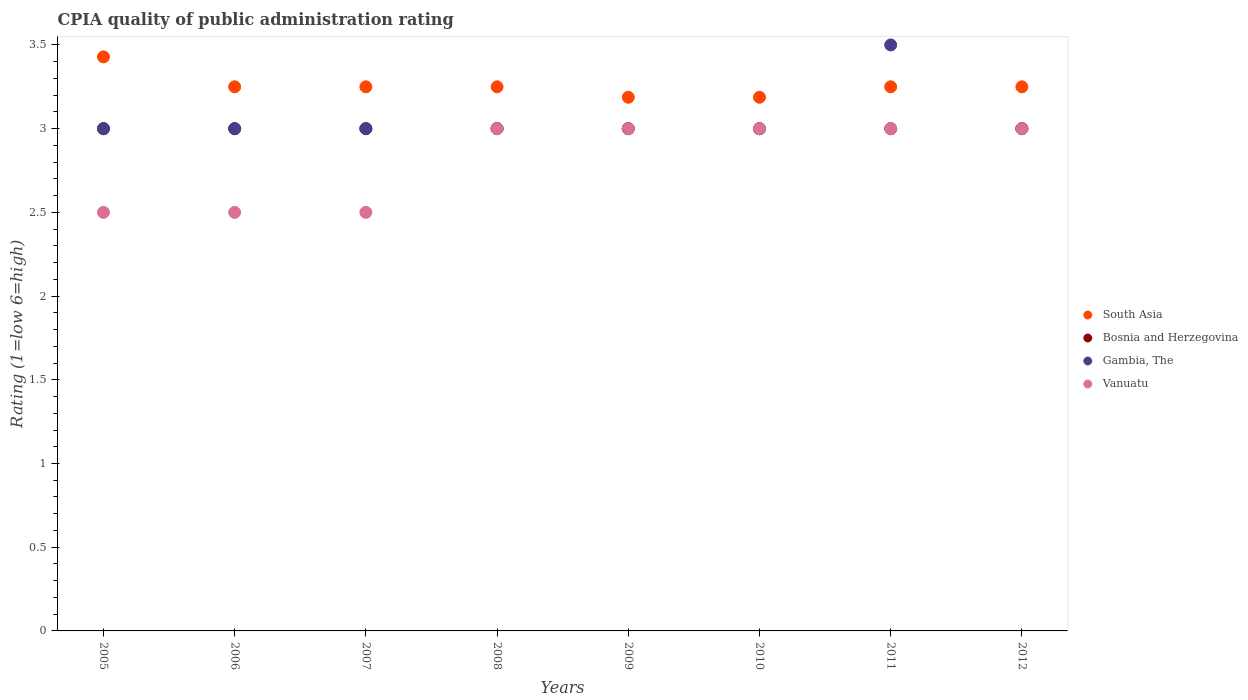What is the CPIA rating in Vanuatu in 2011?
Offer a terse response. 3. In which year was the CPIA rating in Vanuatu minimum?
Provide a short and direct response. 2005. What is the total CPIA rating in Gambia, The in the graph?
Your answer should be compact. 24.5. What is the difference between the CPIA rating in Bosnia and Herzegovina in 2008 and that in 2011?
Your response must be concise. 0. What is the difference between the CPIA rating in South Asia in 2010 and the CPIA rating in Gambia, The in 2007?
Your answer should be very brief. 0.19. What is the ratio of the CPIA rating in Vanuatu in 2007 to that in 2010?
Provide a short and direct response. 0.83. Is the CPIA rating in South Asia in 2006 less than that in 2011?
Your answer should be compact. No. What is the difference between the highest and the second highest CPIA rating in Bosnia and Herzegovina?
Your answer should be compact. 0. What is the difference between the highest and the lowest CPIA rating in South Asia?
Your response must be concise. 0.24. In how many years, is the CPIA rating in Gambia, The greater than the average CPIA rating in Gambia, The taken over all years?
Ensure brevity in your answer.  1. Is the sum of the CPIA rating in Gambia, The in 2005 and 2008 greater than the maximum CPIA rating in South Asia across all years?
Give a very brief answer. Yes. Is it the case that in every year, the sum of the CPIA rating in Gambia, The and CPIA rating in South Asia  is greater than the sum of CPIA rating in Vanuatu and CPIA rating in Bosnia and Herzegovina?
Offer a very short reply. Yes. Is it the case that in every year, the sum of the CPIA rating in Vanuatu and CPIA rating in Bosnia and Herzegovina  is greater than the CPIA rating in Gambia, The?
Offer a very short reply. Yes. Is the CPIA rating in Gambia, The strictly greater than the CPIA rating in South Asia over the years?
Provide a succinct answer. No. How many dotlines are there?
Make the answer very short. 4. How many years are there in the graph?
Ensure brevity in your answer.  8. What is the difference between two consecutive major ticks on the Y-axis?
Your answer should be very brief. 0.5. Does the graph contain grids?
Your answer should be very brief. No. What is the title of the graph?
Keep it short and to the point. CPIA quality of public administration rating. What is the label or title of the X-axis?
Give a very brief answer. Years. What is the Rating (1=low 6=high) in South Asia in 2005?
Provide a short and direct response. 3.43. What is the Rating (1=low 6=high) in Vanuatu in 2005?
Your answer should be compact. 2.5. What is the Rating (1=low 6=high) of Gambia, The in 2006?
Ensure brevity in your answer.  3. What is the Rating (1=low 6=high) of Vanuatu in 2006?
Your answer should be very brief. 2.5. What is the Rating (1=low 6=high) in Bosnia and Herzegovina in 2007?
Give a very brief answer. 3. What is the Rating (1=low 6=high) in Vanuatu in 2007?
Keep it short and to the point. 2.5. What is the Rating (1=low 6=high) in South Asia in 2008?
Offer a terse response. 3.25. What is the Rating (1=low 6=high) of Bosnia and Herzegovina in 2008?
Ensure brevity in your answer.  3. What is the Rating (1=low 6=high) of Gambia, The in 2008?
Your response must be concise. 3. What is the Rating (1=low 6=high) in Vanuatu in 2008?
Your answer should be very brief. 3. What is the Rating (1=low 6=high) of South Asia in 2009?
Offer a very short reply. 3.19. What is the Rating (1=low 6=high) in Bosnia and Herzegovina in 2009?
Your response must be concise. 3. What is the Rating (1=low 6=high) of Vanuatu in 2009?
Provide a succinct answer. 3. What is the Rating (1=low 6=high) of South Asia in 2010?
Offer a very short reply. 3.19. What is the Rating (1=low 6=high) of Bosnia and Herzegovina in 2010?
Give a very brief answer. 3. What is the Rating (1=low 6=high) of Vanuatu in 2010?
Provide a short and direct response. 3. What is the Rating (1=low 6=high) of Bosnia and Herzegovina in 2011?
Offer a very short reply. 3. What is the Rating (1=low 6=high) of Vanuatu in 2012?
Your answer should be very brief. 3. Across all years, what is the maximum Rating (1=low 6=high) in South Asia?
Make the answer very short. 3.43. Across all years, what is the maximum Rating (1=low 6=high) in Bosnia and Herzegovina?
Make the answer very short. 3. Across all years, what is the minimum Rating (1=low 6=high) in South Asia?
Ensure brevity in your answer.  3.19. Across all years, what is the minimum Rating (1=low 6=high) of Vanuatu?
Keep it short and to the point. 2.5. What is the total Rating (1=low 6=high) in South Asia in the graph?
Provide a short and direct response. 26.05. What is the total Rating (1=low 6=high) in Bosnia and Herzegovina in the graph?
Provide a succinct answer. 24. What is the total Rating (1=low 6=high) in Gambia, The in the graph?
Make the answer very short. 24.5. What is the total Rating (1=low 6=high) in Vanuatu in the graph?
Offer a terse response. 22.5. What is the difference between the Rating (1=low 6=high) in South Asia in 2005 and that in 2006?
Your response must be concise. 0.18. What is the difference between the Rating (1=low 6=high) in Vanuatu in 2005 and that in 2006?
Offer a very short reply. 0. What is the difference between the Rating (1=low 6=high) of South Asia in 2005 and that in 2007?
Your response must be concise. 0.18. What is the difference between the Rating (1=low 6=high) of Bosnia and Herzegovina in 2005 and that in 2007?
Ensure brevity in your answer.  0. What is the difference between the Rating (1=low 6=high) of Vanuatu in 2005 and that in 2007?
Give a very brief answer. 0. What is the difference between the Rating (1=low 6=high) of South Asia in 2005 and that in 2008?
Provide a succinct answer. 0.18. What is the difference between the Rating (1=low 6=high) in Bosnia and Herzegovina in 2005 and that in 2008?
Ensure brevity in your answer.  0. What is the difference between the Rating (1=low 6=high) in Gambia, The in 2005 and that in 2008?
Offer a very short reply. 0. What is the difference between the Rating (1=low 6=high) of South Asia in 2005 and that in 2009?
Offer a very short reply. 0.24. What is the difference between the Rating (1=low 6=high) in South Asia in 2005 and that in 2010?
Provide a short and direct response. 0.24. What is the difference between the Rating (1=low 6=high) of Vanuatu in 2005 and that in 2010?
Keep it short and to the point. -0.5. What is the difference between the Rating (1=low 6=high) of South Asia in 2005 and that in 2011?
Ensure brevity in your answer.  0.18. What is the difference between the Rating (1=low 6=high) of Gambia, The in 2005 and that in 2011?
Offer a terse response. -0.5. What is the difference between the Rating (1=low 6=high) in Vanuatu in 2005 and that in 2011?
Give a very brief answer. -0.5. What is the difference between the Rating (1=low 6=high) in South Asia in 2005 and that in 2012?
Keep it short and to the point. 0.18. What is the difference between the Rating (1=low 6=high) of Gambia, The in 2005 and that in 2012?
Provide a short and direct response. 0. What is the difference between the Rating (1=low 6=high) in Vanuatu in 2005 and that in 2012?
Give a very brief answer. -0.5. What is the difference between the Rating (1=low 6=high) in South Asia in 2006 and that in 2009?
Offer a very short reply. 0.06. What is the difference between the Rating (1=low 6=high) of Gambia, The in 2006 and that in 2009?
Your response must be concise. 0. What is the difference between the Rating (1=low 6=high) of Vanuatu in 2006 and that in 2009?
Offer a terse response. -0.5. What is the difference between the Rating (1=low 6=high) in South Asia in 2006 and that in 2010?
Give a very brief answer. 0.06. What is the difference between the Rating (1=low 6=high) in Bosnia and Herzegovina in 2006 and that in 2010?
Your answer should be very brief. 0. What is the difference between the Rating (1=low 6=high) in South Asia in 2006 and that in 2011?
Make the answer very short. 0. What is the difference between the Rating (1=low 6=high) in Bosnia and Herzegovina in 2006 and that in 2011?
Your response must be concise. 0. What is the difference between the Rating (1=low 6=high) of Gambia, The in 2006 and that in 2011?
Offer a terse response. -0.5. What is the difference between the Rating (1=low 6=high) in Vanuatu in 2006 and that in 2012?
Give a very brief answer. -0.5. What is the difference between the Rating (1=low 6=high) in Gambia, The in 2007 and that in 2008?
Provide a succinct answer. 0. What is the difference between the Rating (1=low 6=high) in South Asia in 2007 and that in 2009?
Your answer should be very brief. 0.06. What is the difference between the Rating (1=low 6=high) of Vanuatu in 2007 and that in 2009?
Provide a succinct answer. -0.5. What is the difference between the Rating (1=low 6=high) of South Asia in 2007 and that in 2010?
Your answer should be very brief. 0.06. What is the difference between the Rating (1=low 6=high) in Bosnia and Herzegovina in 2007 and that in 2011?
Your response must be concise. 0. What is the difference between the Rating (1=low 6=high) of Vanuatu in 2007 and that in 2011?
Keep it short and to the point. -0.5. What is the difference between the Rating (1=low 6=high) of Bosnia and Herzegovina in 2007 and that in 2012?
Provide a short and direct response. 0. What is the difference between the Rating (1=low 6=high) of Gambia, The in 2007 and that in 2012?
Offer a terse response. 0. What is the difference between the Rating (1=low 6=high) in Vanuatu in 2007 and that in 2012?
Ensure brevity in your answer.  -0.5. What is the difference between the Rating (1=low 6=high) in South Asia in 2008 and that in 2009?
Give a very brief answer. 0.06. What is the difference between the Rating (1=low 6=high) in South Asia in 2008 and that in 2010?
Provide a short and direct response. 0.06. What is the difference between the Rating (1=low 6=high) in Bosnia and Herzegovina in 2008 and that in 2010?
Your answer should be very brief. 0. What is the difference between the Rating (1=low 6=high) of Vanuatu in 2008 and that in 2010?
Your answer should be compact. 0. What is the difference between the Rating (1=low 6=high) of Gambia, The in 2008 and that in 2011?
Your answer should be compact. -0.5. What is the difference between the Rating (1=low 6=high) of Vanuatu in 2008 and that in 2011?
Your answer should be very brief. 0. What is the difference between the Rating (1=low 6=high) of South Asia in 2008 and that in 2012?
Offer a very short reply. 0. What is the difference between the Rating (1=low 6=high) of Bosnia and Herzegovina in 2008 and that in 2012?
Your response must be concise. 0. What is the difference between the Rating (1=low 6=high) of Gambia, The in 2008 and that in 2012?
Your response must be concise. 0. What is the difference between the Rating (1=low 6=high) in Bosnia and Herzegovina in 2009 and that in 2010?
Your response must be concise. 0. What is the difference between the Rating (1=low 6=high) in South Asia in 2009 and that in 2011?
Your answer should be compact. -0.06. What is the difference between the Rating (1=low 6=high) of Bosnia and Herzegovina in 2009 and that in 2011?
Your answer should be very brief. 0. What is the difference between the Rating (1=low 6=high) of South Asia in 2009 and that in 2012?
Offer a terse response. -0.06. What is the difference between the Rating (1=low 6=high) in Bosnia and Herzegovina in 2009 and that in 2012?
Provide a short and direct response. 0. What is the difference between the Rating (1=low 6=high) of Vanuatu in 2009 and that in 2012?
Offer a very short reply. 0. What is the difference between the Rating (1=low 6=high) in South Asia in 2010 and that in 2011?
Provide a succinct answer. -0.06. What is the difference between the Rating (1=low 6=high) of Bosnia and Herzegovina in 2010 and that in 2011?
Your answer should be very brief. 0. What is the difference between the Rating (1=low 6=high) in Gambia, The in 2010 and that in 2011?
Give a very brief answer. -0.5. What is the difference between the Rating (1=low 6=high) of South Asia in 2010 and that in 2012?
Offer a very short reply. -0.06. What is the difference between the Rating (1=low 6=high) of Bosnia and Herzegovina in 2010 and that in 2012?
Offer a terse response. 0. What is the difference between the Rating (1=low 6=high) of Gambia, The in 2010 and that in 2012?
Your response must be concise. 0. What is the difference between the Rating (1=low 6=high) in Gambia, The in 2011 and that in 2012?
Make the answer very short. 0.5. What is the difference between the Rating (1=low 6=high) in South Asia in 2005 and the Rating (1=low 6=high) in Bosnia and Herzegovina in 2006?
Provide a succinct answer. 0.43. What is the difference between the Rating (1=low 6=high) in South Asia in 2005 and the Rating (1=low 6=high) in Gambia, The in 2006?
Your answer should be very brief. 0.43. What is the difference between the Rating (1=low 6=high) in South Asia in 2005 and the Rating (1=low 6=high) in Bosnia and Herzegovina in 2007?
Your answer should be very brief. 0.43. What is the difference between the Rating (1=low 6=high) in South Asia in 2005 and the Rating (1=low 6=high) in Gambia, The in 2007?
Make the answer very short. 0.43. What is the difference between the Rating (1=low 6=high) of South Asia in 2005 and the Rating (1=low 6=high) of Vanuatu in 2007?
Your answer should be very brief. 0.93. What is the difference between the Rating (1=low 6=high) of Bosnia and Herzegovina in 2005 and the Rating (1=low 6=high) of Gambia, The in 2007?
Keep it short and to the point. 0. What is the difference between the Rating (1=low 6=high) in Gambia, The in 2005 and the Rating (1=low 6=high) in Vanuatu in 2007?
Offer a terse response. 0.5. What is the difference between the Rating (1=low 6=high) of South Asia in 2005 and the Rating (1=low 6=high) of Bosnia and Herzegovina in 2008?
Offer a terse response. 0.43. What is the difference between the Rating (1=low 6=high) in South Asia in 2005 and the Rating (1=low 6=high) in Gambia, The in 2008?
Offer a terse response. 0.43. What is the difference between the Rating (1=low 6=high) of South Asia in 2005 and the Rating (1=low 6=high) of Vanuatu in 2008?
Your answer should be compact. 0.43. What is the difference between the Rating (1=low 6=high) of Bosnia and Herzegovina in 2005 and the Rating (1=low 6=high) of Gambia, The in 2008?
Your response must be concise. 0. What is the difference between the Rating (1=low 6=high) in Bosnia and Herzegovina in 2005 and the Rating (1=low 6=high) in Vanuatu in 2008?
Keep it short and to the point. 0. What is the difference between the Rating (1=low 6=high) in Gambia, The in 2005 and the Rating (1=low 6=high) in Vanuatu in 2008?
Keep it short and to the point. 0. What is the difference between the Rating (1=low 6=high) of South Asia in 2005 and the Rating (1=low 6=high) of Bosnia and Herzegovina in 2009?
Provide a short and direct response. 0.43. What is the difference between the Rating (1=low 6=high) in South Asia in 2005 and the Rating (1=low 6=high) in Gambia, The in 2009?
Ensure brevity in your answer.  0.43. What is the difference between the Rating (1=low 6=high) in South Asia in 2005 and the Rating (1=low 6=high) in Vanuatu in 2009?
Provide a short and direct response. 0.43. What is the difference between the Rating (1=low 6=high) of Bosnia and Herzegovina in 2005 and the Rating (1=low 6=high) of Vanuatu in 2009?
Keep it short and to the point. 0. What is the difference between the Rating (1=low 6=high) in South Asia in 2005 and the Rating (1=low 6=high) in Bosnia and Herzegovina in 2010?
Provide a short and direct response. 0.43. What is the difference between the Rating (1=low 6=high) of South Asia in 2005 and the Rating (1=low 6=high) of Gambia, The in 2010?
Your answer should be very brief. 0.43. What is the difference between the Rating (1=low 6=high) in South Asia in 2005 and the Rating (1=low 6=high) in Vanuatu in 2010?
Provide a short and direct response. 0.43. What is the difference between the Rating (1=low 6=high) of Bosnia and Herzegovina in 2005 and the Rating (1=low 6=high) of Gambia, The in 2010?
Keep it short and to the point. 0. What is the difference between the Rating (1=low 6=high) in Bosnia and Herzegovina in 2005 and the Rating (1=low 6=high) in Vanuatu in 2010?
Provide a succinct answer. 0. What is the difference between the Rating (1=low 6=high) of Gambia, The in 2005 and the Rating (1=low 6=high) of Vanuatu in 2010?
Your response must be concise. 0. What is the difference between the Rating (1=low 6=high) in South Asia in 2005 and the Rating (1=low 6=high) in Bosnia and Herzegovina in 2011?
Offer a terse response. 0.43. What is the difference between the Rating (1=low 6=high) of South Asia in 2005 and the Rating (1=low 6=high) of Gambia, The in 2011?
Offer a very short reply. -0.07. What is the difference between the Rating (1=low 6=high) of South Asia in 2005 and the Rating (1=low 6=high) of Vanuatu in 2011?
Your answer should be very brief. 0.43. What is the difference between the Rating (1=low 6=high) in Bosnia and Herzegovina in 2005 and the Rating (1=low 6=high) in Gambia, The in 2011?
Offer a very short reply. -0.5. What is the difference between the Rating (1=low 6=high) in Gambia, The in 2005 and the Rating (1=low 6=high) in Vanuatu in 2011?
Your response must be concise. 0. What is the difference between the Rating (1=low 6=high) of South Asia in 2005 and the Rating (1=low 6=high) of Bosnia and Herzegovina in 2012?
Keep it short and to the point. 0.43. What is the difference between the Rating (1=low 6=high) of South Asia in 2005 and the Rating (1=low 6=high) of Gambia, The in 2012?
Offer a very short reply. 0.43. What is the difference between the Rating (1=low 6=high) in South Asia in 2005 and the Rating (1=low 6=high) in Vanuatu in 2012?
Offer a very short reply. 0.43. What is the difference between the Rating (1=low 6=high) in Bosnia and Herzegovina in 2005 and the Rating (1=low 6=high) in Vanuatu in 2012?
Provide a succinct answer. 0. What is the difference between the Rating (1=low 6=high) of South Asia in 2006 and the Rating (1=low 6=high) of Bosnia and Herzegovina in 2007?
Offer a terse response. 0.25. What is the difference between the Rating (1=low 6=high) in South Asia in 2006 and the Rating (1=low 6=high) in Gambia, The in 2007?
Your response must be concise. 0.25. What is the difference between the Rating (1=low 6=high) of South Asia in 2006 and the Rating (1=low 6=high) of Vanuatu in 2007?
Offer a very short reply. 0.75. What is the difference between the Rating (1=low 6=high) of Bosnia and Herzegovina in 2006 and the Rating (1=low 6=high) of Gambia, The in 2007?
Your answer should be compact. 0. What is the difference between the Rating (1=low 6=high) of South Asia in 2006 and the Rating (1=low 6=high) of Bosnia and Herzegovina in 2008?
Your answer should be very brief. 0.25. What is the difference between the Rating (1=low 6=high) in South Asia in 2006 and the Rating (1=low 6=high) in Gambia, The in 2008?
Give a very brief answer. 0.25. What is the difference between the Rating (1=low 6=high) of South Asia in 2006 and the Rating (1=low 6=high) of Vanuatu in 2008?
Your answer should be very brief. 0.25. What is the difference between the Rating (1=low 6=high) of Bosnia and Herzegovina in 2006 and the Rating (1=low 6=high) of Gambia, The in 2008?
Make the answer very short. 0. What is the difference between the Rating (1=low 6=high) of Bosnia and Herzegovina in 2006 and the Rating (1=low 6=high) of Vanuatu in 2008?
Make the answer very short. 0. What is the difference between the Rating (1=low 6=high) in South Asia in 2006 and the Rating (1=low 6=high) in Bosnia and Herzegovina in 2009?
Make the answer very short. 0.25. What is the difference between the Rating (1=low 6=high) in South Asia in 2006 and the Rating (1=low 6=high) in Gambia, The in 2009?
Your answer should be compact. 0.25. What is the difference between the Rating (1=low 6=high) of Bosnia and Herzegovina in 2006 and the Rating (1=low 6=high) of Gambia, The in 2009?
Ensure brevity in your answer.  0. What is the difference between the Rating (1=low 6=high) in Gambia, The in 2006 and the Rating (1=low 6=high) in Vanuatu in 2009?
Ensure brevity in your answer.  0. What is the difference between the Rating (1=low 6=high) of South Asia in 2006 and the Rating (1=low 6=high) of Bosnia and Herzegovina in 2010?
Your answer should be very brief. 0.25. What is the difference between the Rating (1=low 6=high) in Bosnia and Herzegovina in 2006 and the Rating (1=low 6=high) in Gambia, The in 2010?
Your response must be concise. 0. What is the difference between the Rating (1=low 6=high) of Bosnia and Herzegovina in 2006 and the Rating (1=low 6=high) of Vanuatu in 2010?
Keep it short and to the point. 0. What is the difference between the Rating (1=low 6=high) of South Asia in 2006 and the Rating (1=low 6=high) of Bosnia and Herzegovina in 2011?
Provide a succinct answer. 0.25. What is the difference between the Rating (1=low 6=high) in South Asia in 2006 and the Rating (1=low 6=high) in Gambia, The in 2011?
Ensure brevity in your answer.  -0.25. What is the difference between the Rating (1=low 6=high) of Gambia, The in 2006 and the Rating (1=low 6=high) of Vanuatu in 2011?
Your response must be concise. 0. What is the difference between the Rating (1=low 6=high) in South Asia in 2006 and the Rating (1=low 6=high) in Bosnia and Herzegovina in 2012?
Your response must be concise. 0.25. What is the difference between the Rating (1=low 6=high) of Bosnia and Herzegovina in 2006 and the Rating (1=low 6=high) of Gambia, The in 2012?
Your answer should be compact. 0. What is the difference between the Rating (1=low 6=high) of Gambia, The in 2006 and the Rating (1=low 6=high) of Vanuatu in 2012?
Your response must be concise. 0. What is the difference between the Rating (1=low 6=high) in South Asia in 2007 and the Rating (1=low 6=high) in Bosnia and Herzegovina in 2008?
Provide a short and direct response. 0.25. What is the difference between the Rating (1=low 6=high) in South Asia in 2007 and the Rating (1=low 6=high) in Gambia, The in 2008?
Ensure brevity in your answer.  0.25. What is the difference between the Rating (1=low 6=high) of Bosnia and Herzegovina in 2007 and the Rating (1=low 6=high) of Gambia, The in 2008?
Make the answer very short. 0. What is the difference between the Rating (1=low 6=high) of Bosnia and Herzegovina in 2007 and the Rating (1=low 6=high) of Vanuatu in 2008?
Make the answer very short. 0. What is the difference between the Rating (1=low 6=high) in Gambia, The in 2007 and the Rating (1=low 6=high) in Vanuatu in 2008?
Provide a short and direct response. 0. What is the difference between the Rating (1=low 6=high) in South Asia in 2007 and the Rating (1=low 6=high) in Bosnia and Herzegovina in 2009?
Ensure brevity in your answer.  0.25. What is the difference between the Rating (1=low 6=high) in South Asia in 2007 and the Rating (1=low 6=high) in Bosnia and Herzegovina in 2010?
Make the answer very short. 0.25. What is the difference between the Rating (1=low 6=high) of South Asia in 2007 and the Rating (1=low 6=high) of Gambia, The in 2010?
Provide a succinct answer. 0.25. What is the difference between the Rating (1=low 6=high) in Bosnia and Herzegovina in 2007 and the Rating (1=low 6=high) in Gambia, The in 2010?
Provide a succinct answer. 0. What is the difference between the Rating (1=low 6=high) of Gambia, The in 2007 and the Rating (1=low 6=high) of Vanuatu in 2011?
Offer a terse response. 0. What is the difference between the Rating (1=low 6=high) in South Asia in 2007 and the Rating (1=low 6=high) in Bosnia and Herzegovina in 2012?
Your answer should be very brief. 0.25. What is the difference between the Rating (1=low 6=high) in Bosnia and Herzegovina in 2007 and the Rating (1=low 6=high) in Gambia, The in 2012?
Offer a terse response. 0. What is the difference between the Rating (1=low 6=high) in Bosnia and Herzegovina in 2007 and the Rating (1=low 6=high) in Vanuatu in 2012?
Give a very brief answer. 0. What is the difference between the Rating (1=low 6=high) of Gambia, The in 2007 and the Rating (1=low 6=high) of Vanuatu in 2012?
Keep it short and to the point. 0. What is the difference between the Rating (1=low 6=high) in South Asia in 2008 and the Rating (1=low 6=high) in Bosnia and Herzegovina in 2010?
Your answer should be very brief. 0.25. What is the difference between the Rating (1=low 6=high) in South Asia in 2008 and the Rating (1=low 6=high) in Gambia, The in 2010?
Offer a very short reply. 0.25. What is the difference between the Rating (1=low 6=high) in Bosnia and Herzegovina in 2008 and the Rating (1=low 6=high) in Gambia, The in 2010?
Offer a very short reply. 0. What is the difference between the Rating (1=low 6=high) in Bosnia and Herzegovina in 2008 and the Rating (1=low 6=high) in Gambia, The in 2011?
Provide a succinct answer. -0.5. What is the difference between the Rating (1=low 6=high) of Gambia, The in 2008 and the Rating (1=low 6=high) of Vanuatu in 2011?
Give a very brief answer. 0. What is the difference between the Rating (1=low 6=high) in South Asia in 2008 and the Rating (1=low 6=high) in Bosnia and Herzegovina in 2012?
Provide a succinct answer. 0.25. What is the difference between the Rating (1=low 6=high) in Bosnia and Herzegovina in 2008 and the Rating (1=low 6=high) in Gambia, The in 2012?
Your answer should be very brief. 0. What is the difference between the Rating (1=low 6=high) in Bosnia and Herzegovina in 2008 and the Rating (1=low 6=high) in Vanuatu in 2012?
Ensure brevity in your answer.  0. What is the difference between the Rating (1=low 6=high) in South Asia in 2009 and the Rating (1=low 6=high) in Bosnia and Herzegovina in 2010?
Provide a succinct answer. 0.19. What is the difference between the Rating (1=low 6=high) in South Asia in 2009 and the Rating (1=low 6=high) in Gambia, The in 2010?
Offer a terse response. 0.19. What is the difference between the Rating (1=low 6=high) in South Asia in 2009 and the Rating (1=low 6=high) in Vanuatu in 2010?
Provide a succinct answer. 0.19. What is the difference between the Rating (1=low 6=high) of Bosnia and Herzegovina in 2009 and the Rating (1=low 6=high) of Vanuatu in 2010?
Provide a succinct answer. 0. What is the difference between the Rating (1=low 6=high) in Gambia, The in 2009 and the Rating (1=low 6=high) in Vanuatu in 2010?
Offer a terse response. 0. What is the difference between the Rating (1=low 6=high) in South Asia in 2009 and the Rating (1=low 6=high) in Bosnia and Herzegovina in 2011?
Offer a terse response. 0.19. What is the difference between the Rating (1=low 6=high) in South Asia in 2009 and the Rating (1=low 6=high) in Gambia, The in 2011?
Your answer should be very brief. -0.31. What is the difference between the Rating (1=low 6=high) in South Asia in 2009 and the Rating (1=low 6=high) in Vanuatu in 2011?
Your response must be concise. 0.19. What is the difference between the Rating (1=low 6=high) of Bosnia and Herzegovina in 2009 and the Rating (1=low 6=high) of Vanuatu in 2011?
Give a very brief answer. 0. What is the difference between the Rating (1=low 6=high) of Gambia, The in 2009 and the Rating (1=low 6=high) of Vanuatu in 2011?
Provide a short and direct response. 0. What is the difference between the Rating (1=low 6=high) of South Asia in 2009 and the Rating (1=low 6=high) of Bosnia and Herzegovina in 2012?
Make the answer very short. 0.19. What is the difference between the Rating (1=low 6=high) of South Asia in 2009 and the Rating (1=low 6=high) of Gambia, The in 2012?
Provide a succinct answer. 0.19. What is the difference between the Rating (1=low 6=high) in South Asia in 2009 and the Rating (1=low 6=high) in Vanuatu in 2012?
Make the answer very short. 0.19. What is the difference between the Rating (1=low 6=high) of Bosnia and Herzegovina in 2009 and the Rating (1=low 6=high) of Gambia, The in 2012?
Keep it short and to the point. 0. What is the difference between the Rating (1=low 6=high) in Gambia, The in 2009 and the Rating (1=low 6=high) in Vanuatu in 2012?
Offer a terse response. 0. What is the difference between the Rating (1=low 6=high) of South Asia in 2010 and the Rating (1=low 6=high) of Bosnia and Herzegovina in 2011?
Make the answer very short. 0.19. What is the difference between the Rating (1=low 6=high) in South Asia in 2010 and the Rating (1=low 6=high) in Gambia, The in 2011?
Your answer should be very brief. -0.31. What is the difference between the Rating (1=low 6=high) in South Asia in 2010 and the Rating (1=low 6=high) in Vanuatu in 2011?
Make the answer very short. 0.19. What is the difference between the Rating (1=low 6=high) in Bosnia and Herzegovina in 2010 and the Rating (1=low 6=high) in Gambia, The in 2011?
Your response must be concise. -0.5. What is the difference between the Rating (1=low 6=high) in Bosnia and Herzegovina in 2010 and the Rating (1=low 6=high) in Vanuatu in 2011?
Offer a terse response. 0. What is the difference between the Rating (1=low 6=high) in South Asia in 2010 and the Rating (1=low 6=high) in Bosnia and Herzegovina in 2012?
Your response must be concise. 0.19. What is the difference between the Rating (1=low 6=high) in South Asia in 2010 and the Rating (1=low 6=high) in Gambia, The in 2012?
Your answer should be compact. 0.19. What is the difference between the Rating (1=low 6=high) of South Asia in 2010 and the Rating (1=low 6=high) of Vanuatu in 2012?
Offer a terse response. 0.19. What is the difference between the Rating (1=low 6=high) in Bosnia and Herzegovina in 2010 and the Rating (1=low 6=high) in Vanuatu in 2012?
Make the answer very short. 0. What is the difference between the Rating (1=low 6=high) of Gambia, The in 2010 and the Rating (1=low 6=high) of Vanuatu in 2012?
Your answer should be very brief. 0. What is the difference between the Rating (1=low 6=high) of South Asia in 2011 and the Rating (1=low 6=high) of Bosnia and Herzegovina in 2012?
Keep it short and to the point. 0.25. What is the difference between the Rating (1=low 6=high) in South Asia in 2011 and the Rating (1=low 6=high) in Gambia, The in 2012?
Your response must be concise. 0.25. What is the difference between the Rating (1=low 6=high) in Bosnia and Herzegovina in 2011 and the Rating (1=low 6=high) in Gambia, The in 2012?
Offer a very short reply. 0. What is the difference between the Rating (1=low 6=high) in Gambia, The in 2011 and the Rating (1=low 6=high) in Vanuatu in 2012?
Give a very brief answer. 0.5. What is the average Rating (1=low 6=high) of South Asia per year?
Provide a succinct answer. 3.26. What is the average Rating (1=low 6=high) of Gambia, The per year?
Provide a succinct answer. 3.06. What is the average Rating (1=low 6=high) in Vanuatu per year?
Your answer should be very brief. 2.81. In the year 2005, what is the difference between the Rating (1=low 6=high) in South Asia and Rating (1=low 6=high) in Bosnia and Herzegovina?
Give a very brief answer. 0.43. In the year 2005, what is the difference between the Rating (1=low 6=high) of South Asia and Rating (1=low 6=high) of Gambia, The?
Your answer should be very brief. 0.43. In the year 2005, what is the difference between the Rating (1=low 6=high) in South Asia and Rating (1=low 6=high) in Vanuatu?
Your answer should be very brief. 0.93. In the year 2005, what is the difference between the Rating (1=low 6=high) in Bosnia and Herzegovina and Rating (1=low 6=high) in Vanuatu?
Give a very brief answer. 0.5. In the year 2006, what is the difference between the Rating (1=low 6=high) in South Asia and Rating (1=low 6=high) in Bosnia and Herzegovina?
Offer a very short reply. 0.25. In the year 2006, what is the difference between the Rating (1=low 6=high) of South Asia and Rating (1=low 6=high) of Vanuatu?
Your answer should be very brief. 0.75. In the year 2006, what is the difference between the Rating (1=low 6=high) of Bosnia and Herzegovina and Rating (1=low 6=high) of Gambia, The?
Your answer should be compact. 0. In the year 2006, what is the difference between the Rating (1=low 6=high) in Bosnia and Herzegovina and Rating (1=low 6=high) in Vanuatu?
Offer a terse response. 0.5. In the year 2006, what is the difference between the Rating (1=low 6=high) in Gambia, The and Rating (1=low 6=high) in Vanuatu?
Ensure brevity in your answer.  0.5. In the year 2007, what is the difference between the Rating (1=low 6=high) in South Asia and Rating (1=low 6=high) in Bosnia and Herzegovina?
Keep it short and to the point. 0.25. In the year 2007, what is the difference between the Rating (1=low 6=high) of South Asia and Rating (1=low 6=high) of Vanuatu?
Make the answer very short. 0.75. In the year 2007, what is the difference between the Rating (1=low 6=high) in Bosnia and Herzegovina and Rating (1=low 6=high) in Gambia, The?
Provide a succinct answer. 0. In the year 2007, what is the difference between the Rating (1=low 6=high) in Bosnia and Herzegovina and Rating (1=low 6=high) in Vanuatu?
Give a very brief answer. 0.5. In the year 2008, what is the difference between the Rating (1=low 6=high) in South Asia and Rating (1=low 6=high) in Gambia, The?
Offer a very short reply. 0.25. In the year 2008, what is the difference between the Rating (1=low 6=high) of Bosnia and Herzegovina and Rating (1=low 6=high) of Gambia, The?
Offer a very short reply. 0. In the year 2009, what is the difference between the Rating (1=low 6=high) in South Asia and Rating (1=low 6=high) in Bosnia and Herzegovina?
Your answer should be compact. 0.19. In the year 2009, what is the difference between the Rating (1=low 6=high) in South Asia and Rating (1=low 6=high) in Gambia, The?
Your answer should be compact. 0.19. In the year 2009, what is the difference between the Rating (1=low 6=high) in South Asia and Rating (1=low 6=high) in Vanuatu?
Your answer should be very brief. 0.19. In the year 2009, what is the difference between the Rating (1=low 6=high) of Gambia, The and Rating (1=low 6=high) of Vanuatu?
Provide a succinct answer. 0. In the year 2010, what is the difference between the Rating (1=low 6=high) in South Asia and Rating (1=low 6=high) in Bosnia and Herzegovina?
Offer a very short reply. 0.19. In the year 2010, what is the difference between the Rating (1=low 6=high) of South Asia and Rating (1=low 6=high) of Gambia, The?
Ensure brevity in your answer.  0.19. In the year 2010, what is the difference between the Rating (1=low 6=high) of South Asia and Rating (1=low 6=high) of Vanuatu?
Offer a terse response. 0.19. In the year 2010, what is the difference between the Rating (1=low 6=high) of Gambia, The and Rating (1=low 6=high) of Vanuatu?
Your answer should be compact. 0. In the year 2011, what is the difference between the Rating (1=low 6=high) of South Asia and Rating (1=low 6=high) of Bosnia and Herzegovina?
Keep it short and to the point. 0.25. In the year 2011, what is the difference between the Rating (1=low 6=high) in Gambia, The and Rating (1=low 6=high) in Vanuatu?
Your answer should be compact. 0.5. In the year 2012, what is the difference between the Rating (1=low 6=high) of South Asia and Rating (1=low 6=high) of Gambia, The?
Offer a very short reply. 0.25. In the year 2012, what is the difference between the Rating (1=low 6=high) in Bosnia and Herzegovina and Rating (1=low 6=high) in Vanuatu?
Provide a succinct answer. 0. What is the ratio of the Rating (1=low 6=high) of South Asia in 2005 to that in 2006?
Make the answer very short. 1.05. What is the ratio of the Rating (1=low 6=high) in South Asia in 2005 to that in 2007?
Keep it short and to the point. 1.05. What is the ratio of the Rating (1=low 6=high) of Bosnia and Herzegovina in 2005 to that in 2007?
Provide a short and direct response. 1. What is the ratio of the Rating (1=low 6=high) in Gambia, The in 2005 to that in 2007?
Provide a short and direct response. 1. What is the ratio of the Rating (1=low 6=high) of South Asia in 2005 to that in 2008?
Provide a short and direct response. 1.05. What is the ratio of the Rating (1=low 6=high) of Gambia, The in 2005 to that in 2008?
Make the answer very short. 1. What is the ratio of the Rating (1=low 6=high) of South Asia in 2005 to that in 2009?
Provide a succinct answer. 1.08. What is the ratio of the Rating (1=low 6=high) of Bosnia and Herzegovina in 2005 to that in 2009?
Make the answer very short. 1. What is the ratio of the Rating (1=low 6=high) of Vanuatu in 2005 to that in 2009?
Your answer should be compact. 0.83. What is the ratio of the Rating (1=low 6=high) of South Asia in 2005 to that in 2010?
Your answer should be very brief. 1.08. What is the ratio of the Rating (1=low 6=high) of Bosnia and Herzegovina in 2005 to that in 2010?
Make the answer very short. 1. What is the ratio of the Rating (1=low 6=high) of South Asia in 2005 to that in 2011?
Provide a short and direct response. 1.05. What is the ratio of the Rating (1=low 6=high) in Gambia, The in 2005 to that in 2011?
Offer a very short reply. 0.86. What is the ratio of the Rating (1=low 6=high) of South Asia in 2005 to that in 2012?
Give a very brief answer. 1.05. What is the ratio of the Rating (1=low 6=high) of Bosnia and Herzegovina in 2005 to that in 2012?
Make the answer very short. 1. What is the ratio of the Rating (1=low 6=high) of Gambia, The in 2005 to that in 2012?
Offer a terse response. 1. What is the ratio of the Rating (1=low 6=high) of Vanuatu in 2005 to that in 2012?
Your answer should be very brief. 0.83. What is the ratio of the Rating (1=low 6=high) in South Asia in 2006 to that in 2007?
Offer a terse response. 1. What is the ratio of the Rating (1=low 6=high) of Gambia, The in 2006 to that in 2008?
Ensure brevity in your answer.  1. What is the ratio of the Rating (1=low 6=high) in Vanuatu in 2006 to that in 2008?
Keep it short and to the point. 0.83. What is the ratio of the Rating (1=low 6=high) in South Asia in 2006 to that in 2009?
Provide a succinct answer. 1.02. What is the ratio of the Rating (1=low 6=high) of Bosnia and Herzegovina in 2006 to that in 2009?
Your answer should be very brief. 1. What is the ratio of the Rating (1=low 6=high) in Gambia, The in 2006 to that in 2009?
Give a very brief answer. 1. What is the ratio of the Rating (1=low 6=high) in South Asia in 2006 to that in 2010?
Your answer should be compact. 1.02. What is the ratio of the Rating (1=low 6=high) of Bosnia and Herzegovina in 2006 to that in 2010?
Offer a terse response. 1. What is the ratio of the Rating (1=low 6=high) in Gambia, The in 2006 to that in 2010?
Your response must be concise. 1. What is the ratio of the Rating (1=low 6=high) in Gambia, The in 2006 to that in 2011?
Your answer should be compact. 0.86. What is the ratio of the Rating (1=low 6=high) in Vanuatu in 2006 to that in 2011?
Offer a terse response. 0.83. What is the ratio of the Rating (1=low 6=high) of South Asia in 2006 to that in 2012?
Give a very brief answer. 1. What is the ratio of the Rating (1=low 6=high) of Bosnia and Herzegovina in 2007 to that in 2008?
Make the answer very short. 1. What is the ratio of the Rating (1=low 6=high) of South Asia in 2007 to that in 2009?
Offer a terse response. 1.02. What is the ratio of the Rating (1=low 6=high) of Vanuatu in 2007 to that in 2009?
Keep it short and to the point. 0.83. What is the ratio of the Rating (1=low 6=high) in South Asia in 2007 to that in 2010?
Your response must be concise. 1.02. What is the ratio of the Rating (1=low 6=high) in Bosnia and Herzegovina in 2007 to that in 2010?
Make the answer very short. 1. What is the ratio of the Rating (1=low 6=high) of Vanuatu in 2007 to that in 2010?
Your answer should be very brief. 0.83. What is the ratio of the Rating (1=low 6=high) in Gambia, The in 2007 to that in 2011?
Ensure brevity in your answer.  0.86. What is the ratio of the Rating (1=low 6=high) in Vanuatu in 2007 to that in 2011?
Give a very brief answer. 0.83. What is the ratio of the Rating (1=low 6=high) in Gambia, The in 2007 to that in 2012?
Make the answer very short. 1. What is the ratio of the Rating (1=low 6=high) in Vanuatu in 2007 to that in 2012?
Your response must be concise. 0.83. What is the ratio of the Rating (1=low 6=high) in South Asia in 2008 to that in 2009?
Your response must be concise. 1.02. What is the ratio of the Rating (1=low 6=high) in Bosnia and Herzegovina in 2008 to that in 2009?
Give a very brief answer. 1. What is the ratio of the Rating (1=low 6=high) in South Asia in 2008 to that in 2010?
Your answer should be compact. 1.02. What is the ratio of the Rating (1=low 6=high) in Bosnia and Herzegovina in 2008 to that in 2010?
Keep it short and to the point. 1. What is the ratio of the Rating (1=low 6=high) of Bosnia and Herzegovina in 2008 to that in 2011?
Offer a very short reply. 1. What is the ratio of the Rating (1=low 6=high) of Gambia, The in 2008 to that in 2011?
Give a very brief answer. 0.86. What is the ratio of the Rating (1=low 6=high) in Vanuatu in 2008 to that in 2011?
Offer a terse response. 1. What is the ratio of the Rating (1=low 6=high) in South Asia in 2008 to that in 2012?
Give a very brief answer. 1. What is the ratio of the Rating (1=low 6=high) in Bosnia and Herzegovina in 2008 to that in 2012?
Provide a succinct answer. 1. What is the ratio of the Rating (1=low 6=high) of Vanuatu in 2008 to that in 2012?
Ensure brevity in your answer.  1. What is the ratio of the Rating (1=low 6=high) of South Asia in 2009 to that in 2011?
Keep it short and to the point. 0.98. What is the ratio of the Rating (1=low 6=high) of Gambia, The in 2009 to that in 2011?
Give a very brief answer. 0.86. What is the ratio of the Rating (1=low 6=high) in Vanuatu in 2009 to that in 2011?
Make the answer very short. 1. What is the ratio of the Rating (1=low 6=high) of South Asia in 2009 to that in 2012?
Provide a succinct answer. 0.98. What is the ratio of the Rating (1=low 6=high) in Bosnia and Herzegovina in 2009 to that in 2012?
Your answer should be compact. 1. What is the ratio of the Rating (1=low 6=high) of South Asia in 2010 to that in 2011?
Offer a terse response. 0.98. What is the ratio of the Rating (1=low 6=high) in Bosnia and Herzegovina in 2010 to that in 2011?
Make the answer very short. 1. What is the ratio of the Rating (1=low 6=high) of Vanuatu in 2010 to that in 2011?
Your response must be concise. 1. What is the ratio of the Rating (1=low 6=high) in South Asia in 2010 to that in 2012?
Ensure brevity in your answer.  0.98. What is the ratio of the Rating (1=low 6=high) in Bosnia and Herzegovina in 2010 to that in 2012?
Offer a terse response. 1. What is the ratio of the Rating (1=low 6=high) of Vanuatu in 2010 to that in 2012?
Give a very brief answer. 1. What is the ratio of the Rating (1=low 6=high) of Gambia, The in 2011 to that in 2012?
Your answer should be compact. 1.17. What is the ratio of the Rating (1=low 6=high) in Vanuatu in 2011 to that in 2012?
Offer a very short reply. 1. What is the difference between the highest and the second highest Rating (1=low 6=high) in South Asia?
Your answer should be very brief. 0.18. What is the difference between the highest and the second highest Rating (1=low 6=high) of Gambia, The?
Keep it short and to the point. 0.5. What is the difference between the highest and the lowest Rating (1=low 6=high) of South Asia?
Give a very brief answer. 0.24. What is the difference between the highest and the lowest Rating (1=low 6=high) of Bosnia and Herzegovina?
Provide a succinct answer. 0. What is the difference between the highest and the lowest Rating (1=low 6=high) in Gambia, The?
Keep it short and to the point. 0.5. 